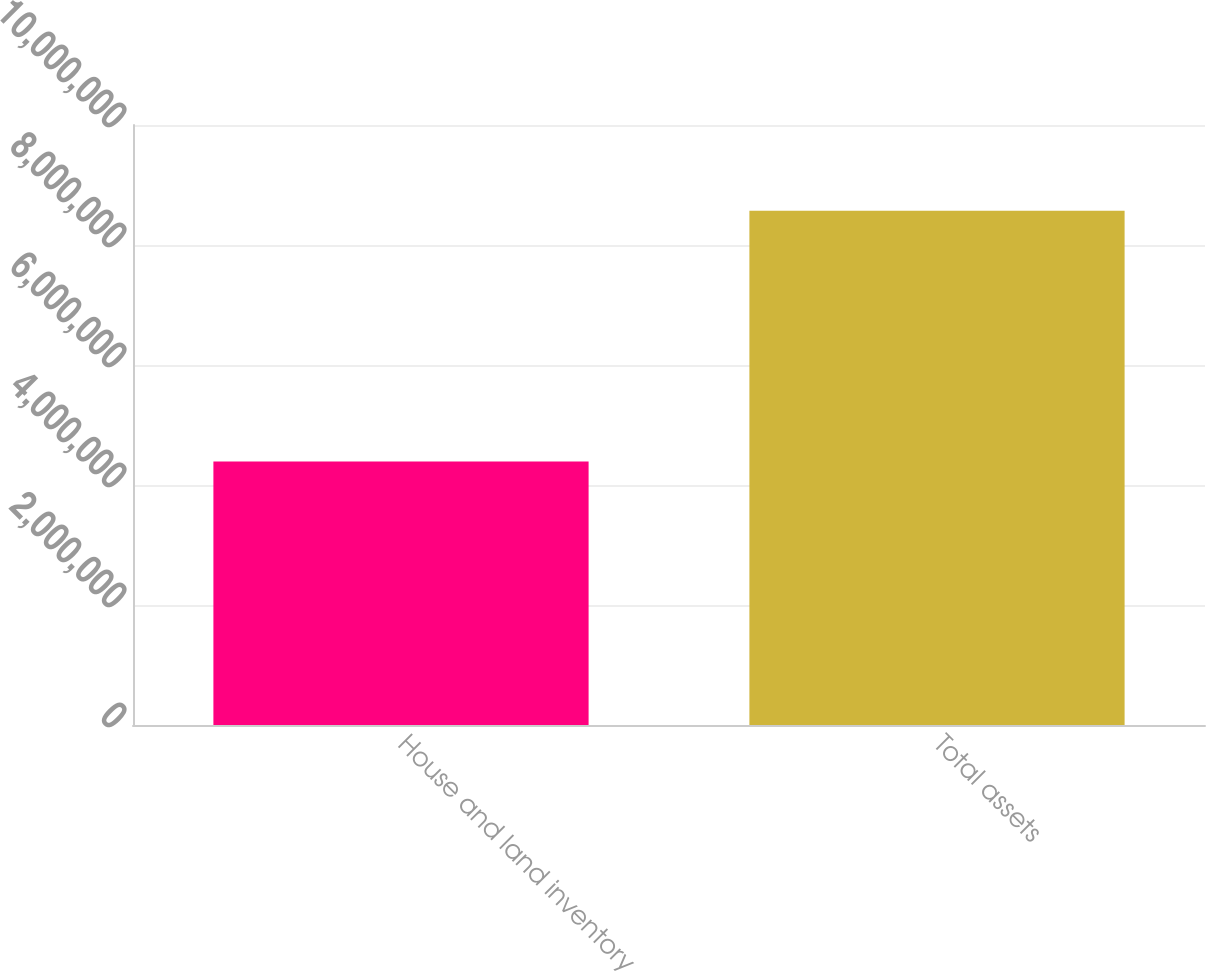Convert chart. <chart><loc_0><loc_0><loc_500><loc_500><bar_chart><fcel>House and land inventory<fcel>Total assets<nl><fcel>4.3921e+06<fcel>8.56941e+06<nl></chart> 